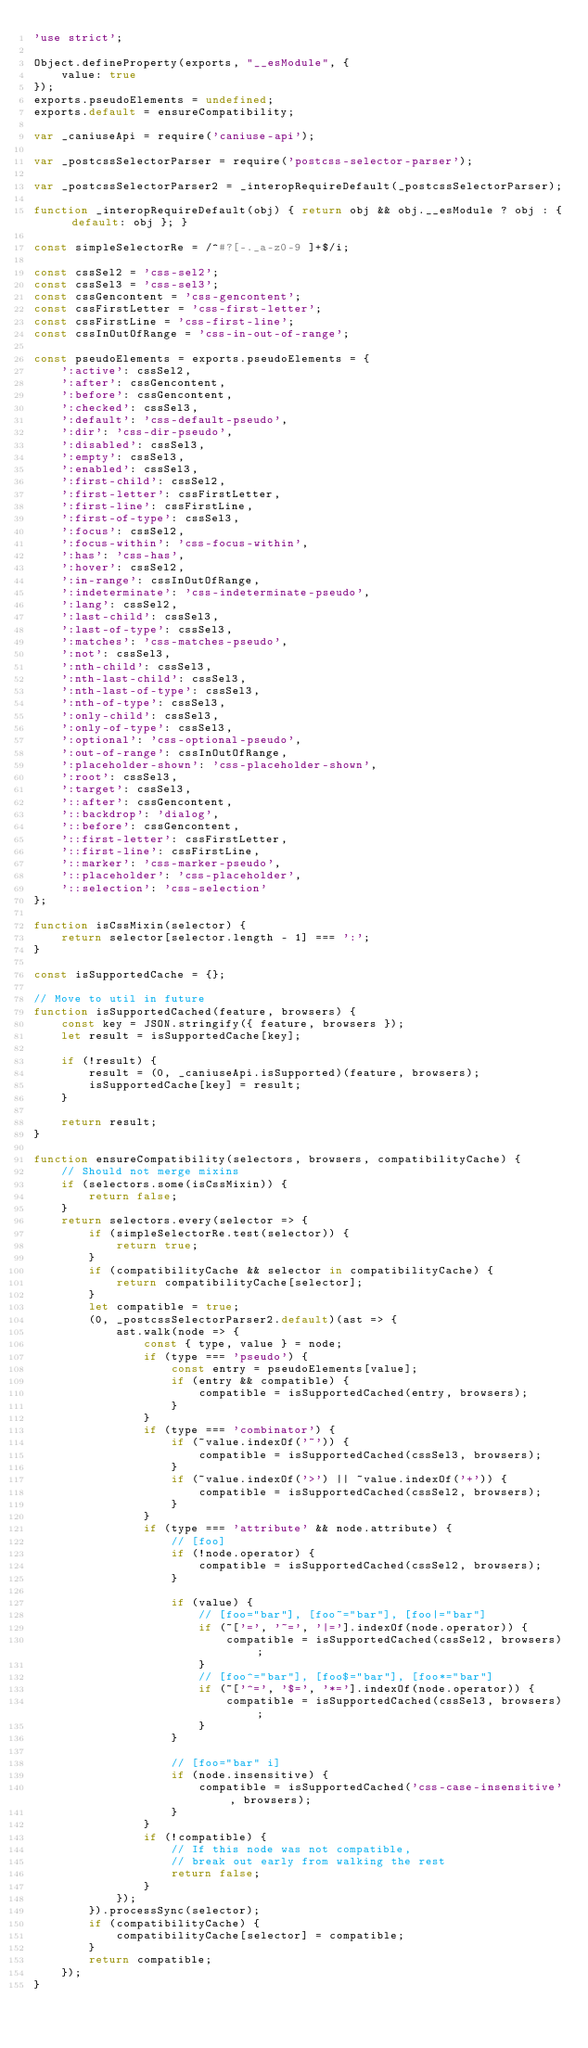<code> <loc_0><loc_0><loc_500><loc_500><_JavaScript_>'use strict';

Object.defineProperty(exports, "__esModule", {
    value: true
});
exports.pseudoElements = undefined;
exports.default = ensureCompatibility;

var _caniuseApi = require('caniuse-api');

var _postcssSelectorParser = require('postcss-selector-parser');

var _postcssSelectorParser2 = _interopRequireDefault(_postcssSelectorParser);

function _interopRequireDefault(obj) { return obj && obj.__esModule ? obj : { default: obj }; }

const simpleSelectorRe = /^#?[-._a-z0-9 ]+$/i;

const cssSel2 = 'css-sel2';
const cssSel3 = 'css-sel3';
const cssGencontent = 'css-gencontent';
const cssFirstLetter = 'css-first-letter';
const cssFirstLine = 'css-first-line';
const cssInOutOfRange = 'css-in-out-of-range';

const pseudoElements = exports.pseudoElements = {
    ':active': cssSel2,
    ':after': cssGencontent,
    ':before': cssGencontent,
    ':checked': cssSel3,
    ':default': 'css-default-pseudo',
    ':dir': 'css-dir-pseudo',
    ':disabled': cssSel3,
    ':empty': cssSel3,
    ':enabled': cssSel3,
    ':first-child': cssSel2,
    ':first-letter': cssFirstLetter,
    ':first-line': cssFirstLine,
    ':first-of-type': cssSel3,
    ':focus': cssSel2,
    ':focus-within': 'css-focus-within',
    ':has': 'css-has',
    ':hover': cssSel2,
    ':in-range': cssInOutOfRange,
    ':indeterminate': 'css-indeterminate-pseudo',
    ':lang': cssSel2,
    ':last-child': cssSel3,
    ':last-of-type': cssSel3,
    ':matches': 'css-matches-pseudo',
    ':not': cssSel3,
    ':nth-child': cssSel3,
    ':nth-last-child': cssSel3,
    ':nth-last-of-type': cssSel3,
    ':nth-of-type': cssSel3,
    ':only-child': cssSel3,
    ':only-of-type': cssSel3,
    ':optional': 'css-optional-pseudo',
    ':out-of-range': cssInOutOfRange,
    ':placeholder-shown': 'css-placeholder-shown',
    ':root': cssSel3,
    ':target': cssSel3,
    '::after': cssGencontent,
    '::backdrop': 'dialog',
    '::before': cssGencontent,
    '::first-letter': cssFirstLetter,
    '::first-line': cssFirstLine,
    '::marker': 'css-marker-pseudo',
    '::placeholder': 'css-placeholder',
    '::selection': 'css-selection'
};

function isCssMixin(selector) {
    return selector[selector.length - 1] === ':';
}

const isSupportedCache = {};

// Move to util in future
function isSupportedCached(feature, browsers) {
    const key = JSON.stringify({ feature, browsers });
    let result = isSupportedCache[key];

    if (!result) {
        result = (0, _caniuseApi.isSupported)(feature, browsers);
        isSupportedCache[key] = result;
    }

    return result;
}

function ensureCompatibility(selectors, browsers, compatibilityCache) {
    // Should not merge mixins
    if (selectors.some(isCssMixin)) {
        return false;
    }
    return selectors.every(selector => {
        if (simpleSelectorRe.test(selector)) {
            return true;
        }
        if (compatibilityCache && selector in compatibilityCache) {
            return compatibilityCache[selector];
        }
        let compatible = true;
        (0, _postcssSelectorParser2.default)(ast => {
            ast.walk(node => {
                const { type, value } = node;
                if (type === 'pseudo') {
                    const entry = pseudoElements[value];
                    if (entry && compatible) {
                        compatible = isSupportedCached(entry, browsers);
                    }
                }
                if (type === 'combinator') {
                    if (~value.indexOf('~')) {
                        compatible = isSupportedCached(cssSel3, browsers);
                    }
                    if (~value.indexOf('>') || ~value.indexOf('+')) {
                        compatible = isSupportedCached(cssSel2, browsers);
                    }
                }
                if (type === 'attribute' && node.attribute) {
                    // [foo]
                    if (!node.operator) {
                        compatible = isSupportedCached(cssSel2, browsers);
                    }

                    if (value) {
                        // [foo="bar"], [foo~="bar"], [foo|="bar"]
                        if (~['=', '~=', '|='].indexOf(node.operator)) {
                            compatible = isSupportedCached(cssSel2, browsers);
                        }
                        // [foo^="bar"], [foo$="bar"], [foo*="bar"]
                        if (~['^=', '$=', '*='].indexOf(node.operator)) {
                            compatible = isSupportedCached(cssSel3, browsers);
                        }
                    }

                    // [foo="bar" i]
                    if (node.insensitive) {
                        compatible = isSupportedCached('css-case-insensitive', browsers);
                    }
                }
                if (!compatible) {
                    // If this node was not compatible,
                    // break out early from walking the rest
                    return false;
                }
            });
        }).processSync(selector);
        if (compatibilityCache) {
            compatibilityCache[selector] = compatible;
        }
        return compatible;
    });
}</code> 